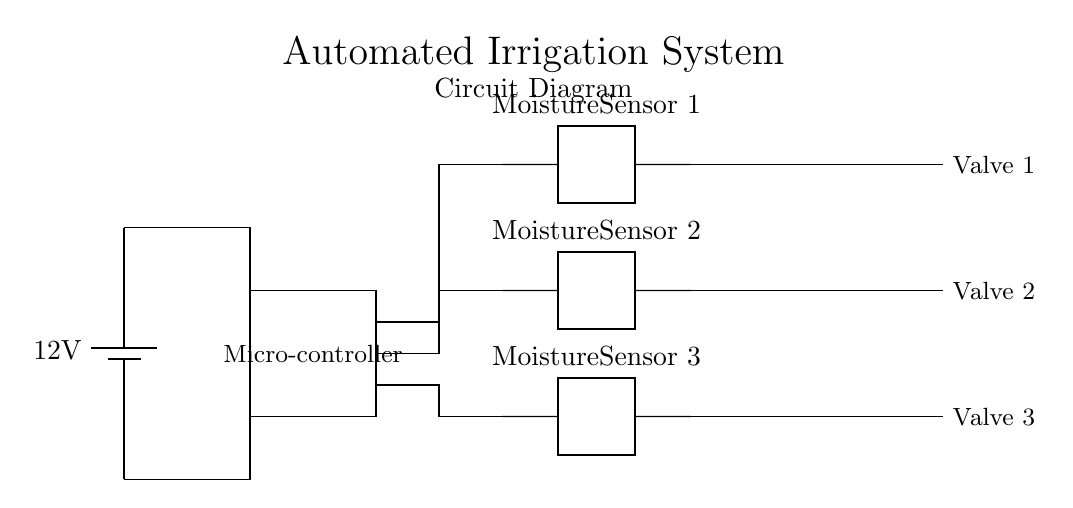What is the voltage of this circuit? The voltage is 12V, which is indicated by the battery symbol in the circuit diagram.
Answer: 12V How many moisture sensors are present? There are three moisture sensors labeled in the diagram, which are shown as two-port components.
Answer: Three What do the solenoid valves control? The solenoid valves control the flow of water in the irrigation system, opening and closing based on signals from the moisture sensors and microcontroller.
Answer: Water flow What is the function of the microcontroller in this system? The microcontroller processes data from the moisture sensors and sends signals to the solenoid valves to control irrigation based on soil moisture levels.
Answer: Automation Which component receives input from the moisture sensors? The microcontroller receives input from the moisture sensors, which are connected directly to its input ports as illustrated in the connections of the diagram.
Answer: Microcontroller What action happens when the soil moisture is low? When the soil moisture is low, the moisture sensors detect this condition and signal the microcontroller to open the solenoid valves for irrigation.
Answer: Irrigation 